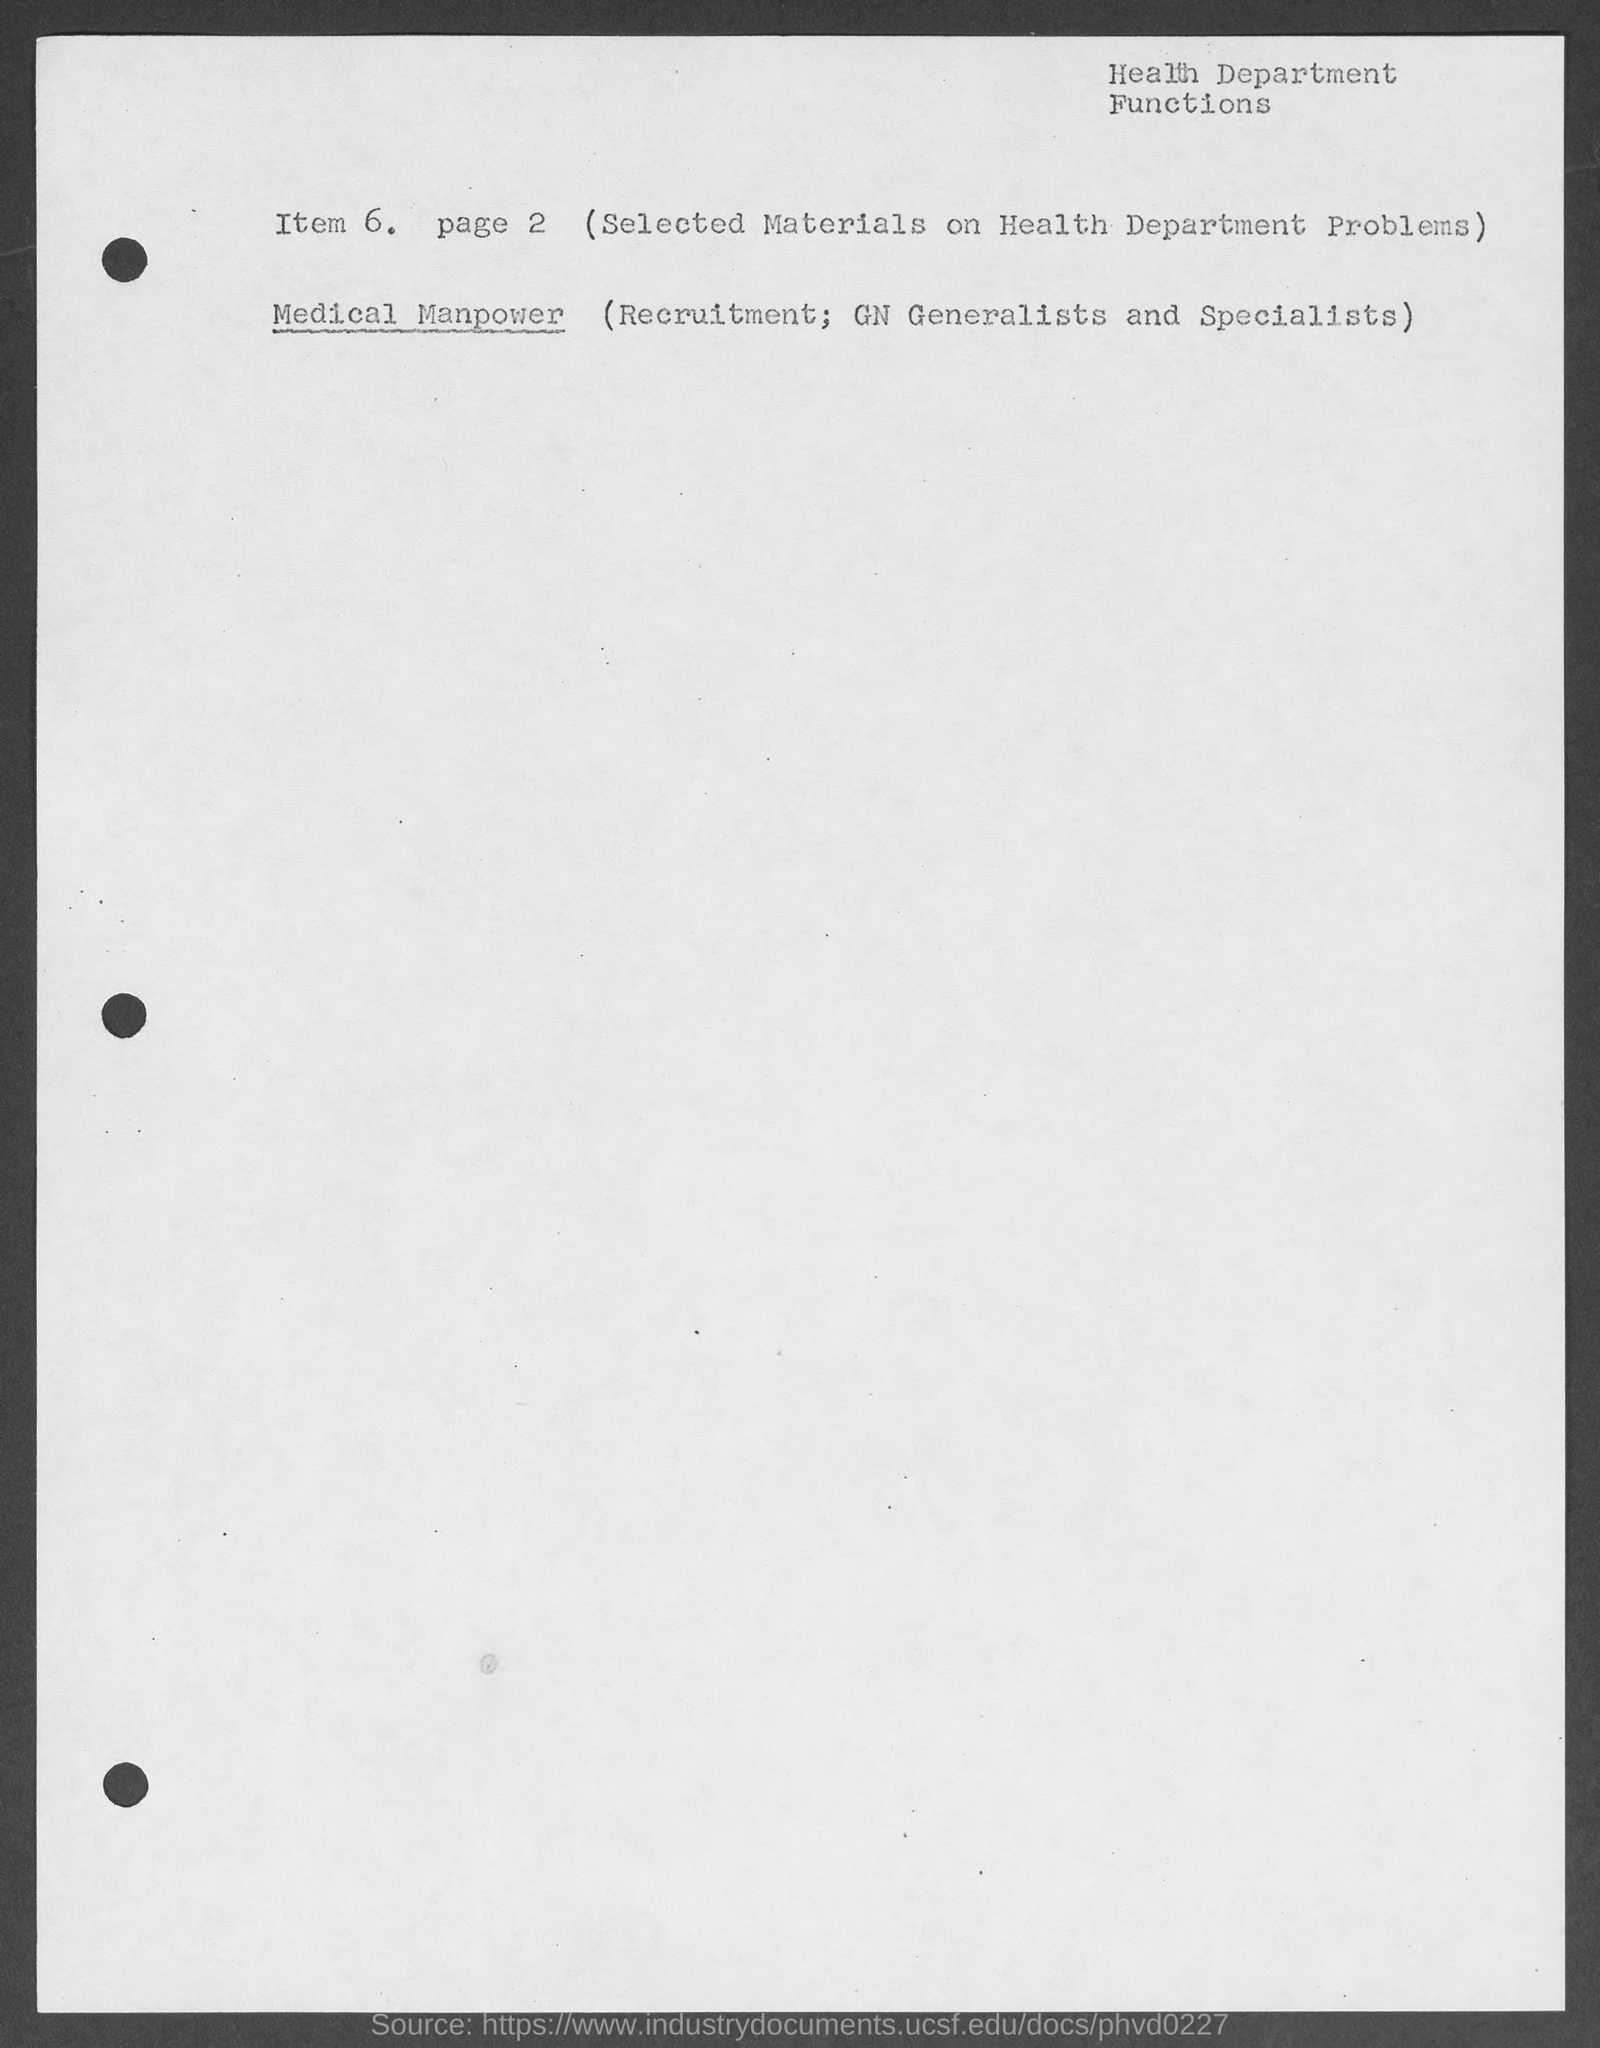What is written on the top-right of the document?
Keep it short and to the point. Health Department Functions. What is number of the page mentioned?
Provide a short and direct response. Page 2. 